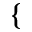<formula> <loc_0><loc_0><loc_500><loc_500>\{</formula> 